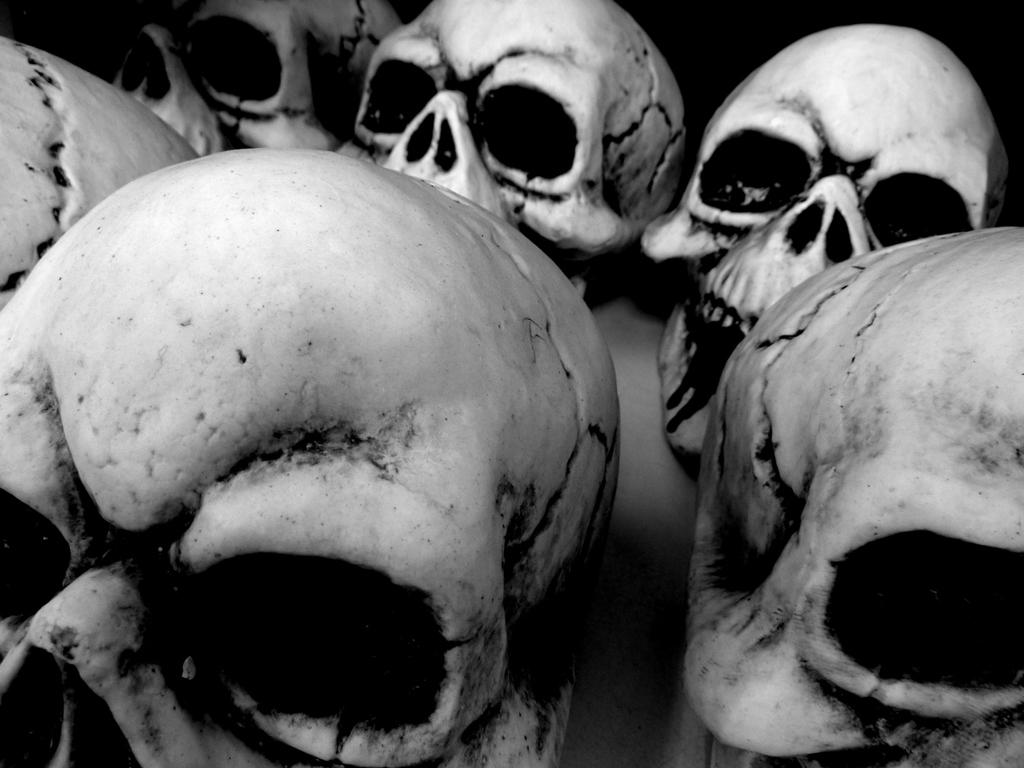What type of objects are present in the image? There are human skulls in the image. What type of polish is used on the yak's fur in the image? There is no yak or polish present in the image; it only features human skulls. 